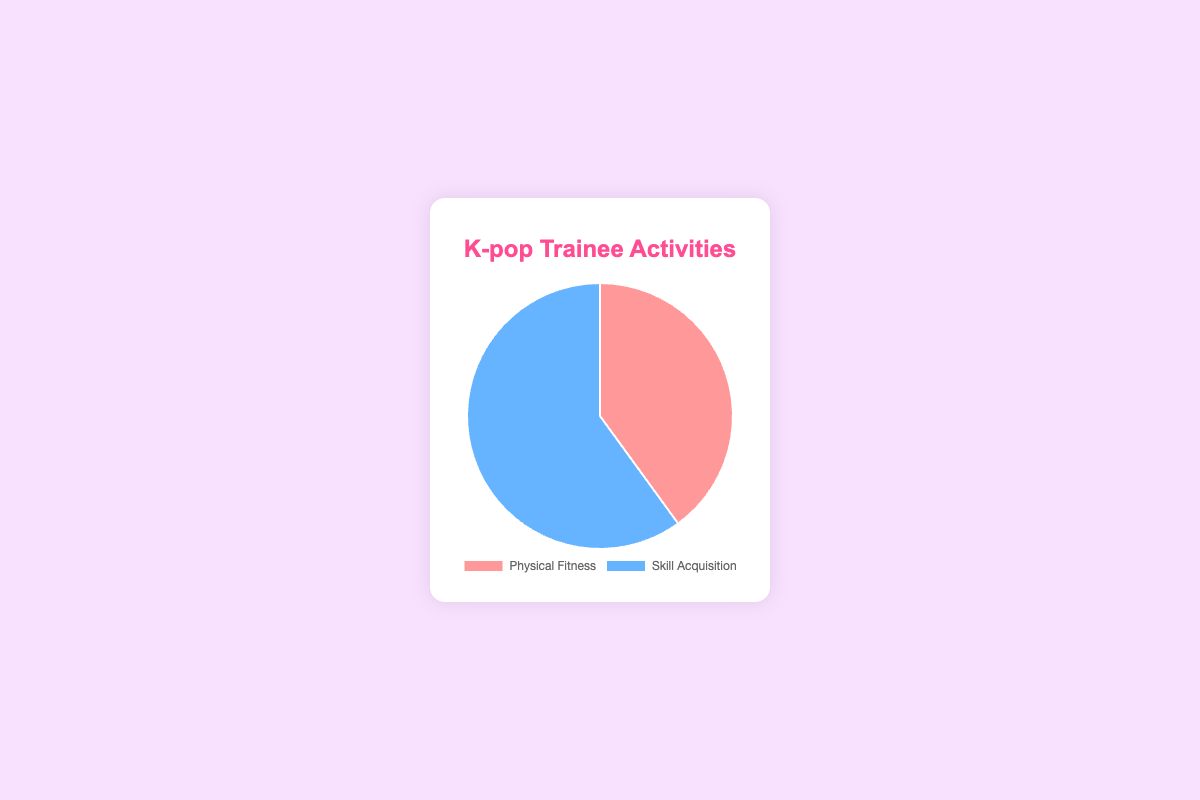What is the proportion of time spent on Physical Fitness activities? The pie chart shows that 40% of the activities are dedicated to Physical Fitness, as indicated by the slice labeled "Physical Fitness."
Answer: 40% What is the proportion of time spent on Skill Acquisition activities? The pie chart shows that 60% of the activities are dedicated to Skill Acquisition, as indicated by the slice labeled "Skill Acquisition."
Answer: 60% Which activity has the greater proportion of time spent on it? By comparing the two slices in the pie chart, it's clear that Skill Acquisition (60%) has a greater proportion of time spent on it than Physical Fitness (40%).
Answer: Skill Acquisition What is the difference in the time spent between Skill Acquisition and Physical Fitness activities? The pie chart states that 60% is spent on Skill Acquisition and 40% on Physical Fitness. The difference is calculated as 60% - 40%.
Answer: 20% If the total time allocated to activities is 5 hours, how many hours are spent on Physical Fitness? Given Physical Fitness activities take up 40% of the time, you calculate 40% of 5 hours as 0.4 * 5 = 2 hours.
Answer: 2 hours What color represents the Physical Fitness activities in the pie chart? The Physical Fitness slice in the pie chart is shaded in red.
Answer: Red If the overall time spent on activities changes to 10 hours, how many hours should now be spent on Skill Acquisition activities? Given that Skill Acquisition takes up 60% of the time, calculate 60% of 10 hours: 0.6 * 10 = 6 hours.
Answer: 6 hours What is the combined proportion of time spent on both activities? The pie chart shows two slices, one for Physical Fitness (40%) and one for Skill Acquisition (60%). Summing these proportions gives 40% + 60%.
Answer: 100% If the pie chart was redrawn to show a third activity taking up 20% of the time, what would be the new proportion for Skill Acquisition if it equally shares the remaining time with Physical Fitness? First, remove the 20% allocated to the new activity from the total 100%, leaving 80%. Then, split the remaining 80% equally between the two original activities. 80% / 2 = 40%.
Answer: 40% How does the visual size of the Skill Acquisition slice compare to the Physical Fitness slice? The Skill Acquisition slice visually appears larger, covering more of the pie chart (60%) compared to the smaller Physical Fitness slice (40%).
Answer: Larger than 